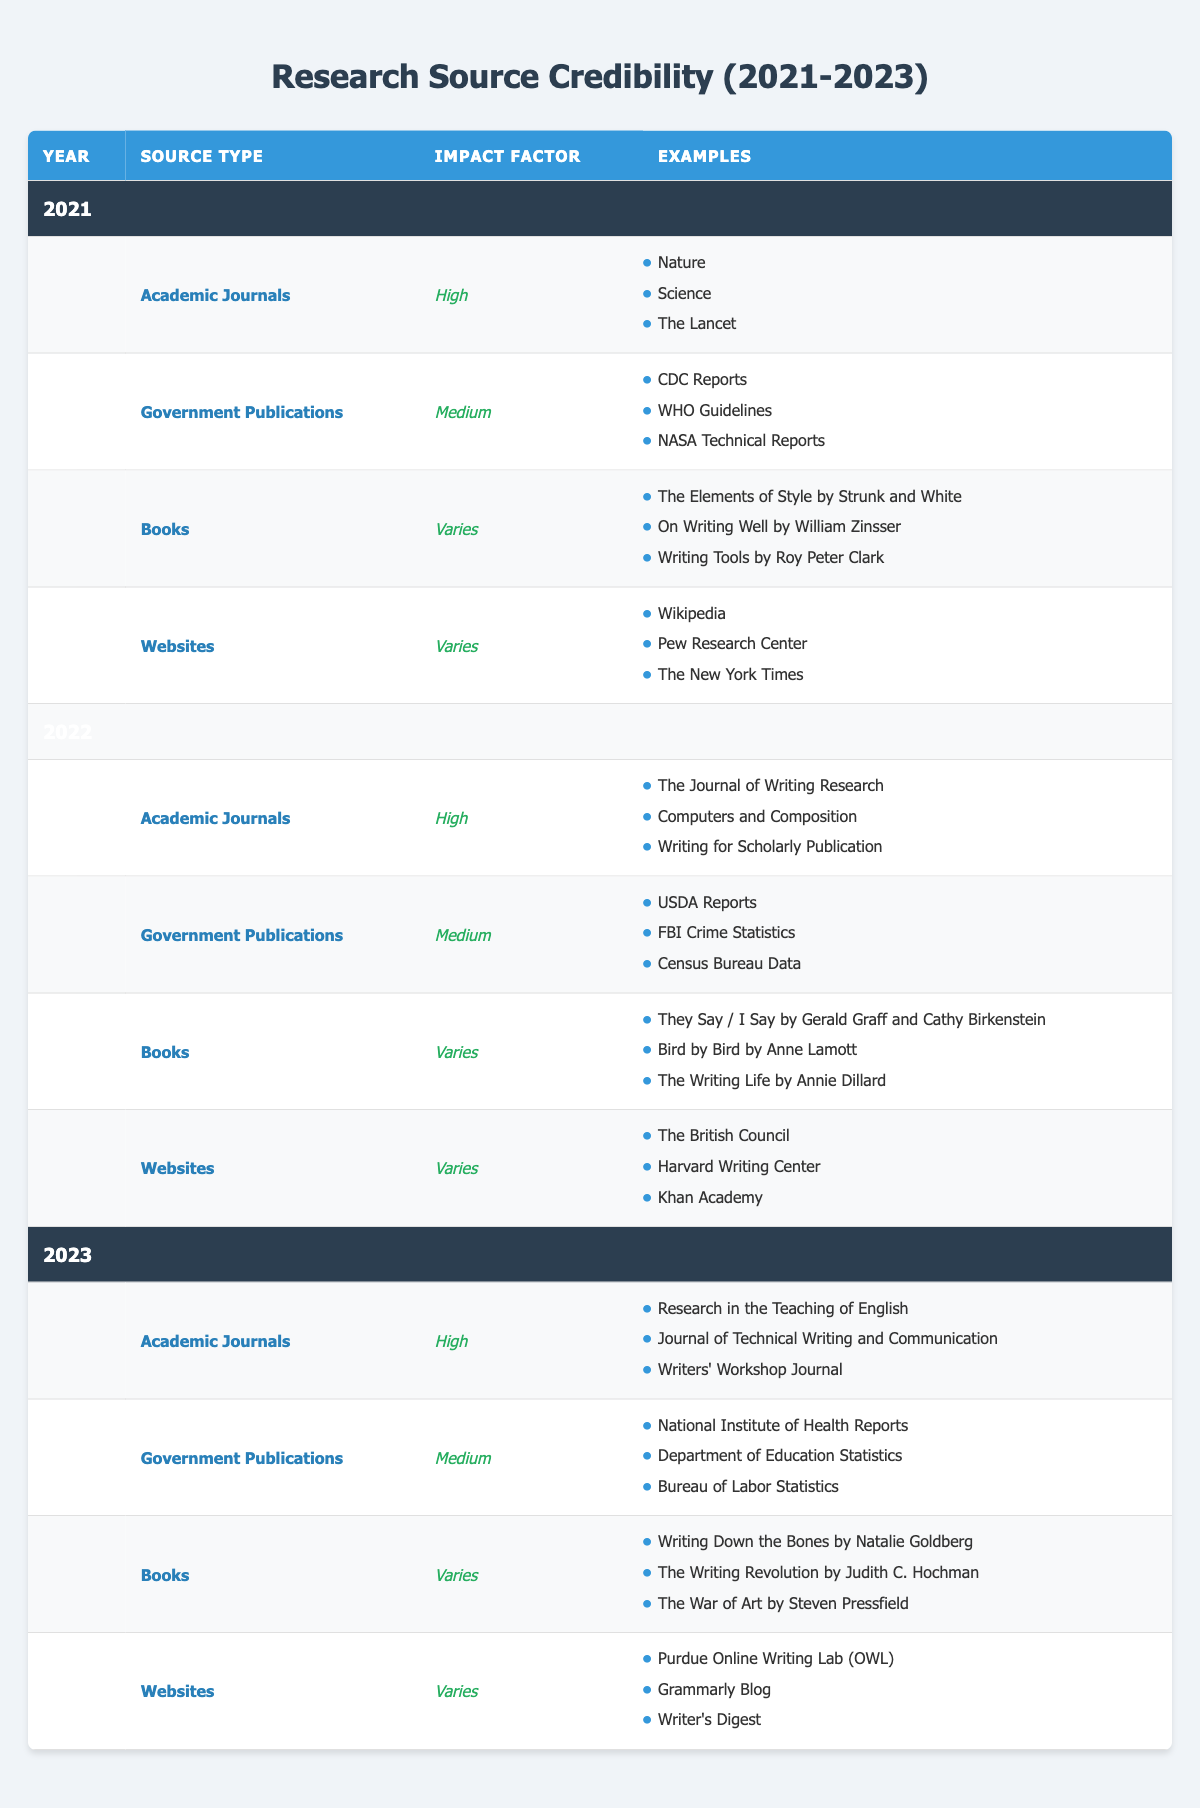What is the impact factor for Academic Journals in 2023? The table shows that the impact factor for Academic Journals in 2023 is categorized as "High."
Answer: High Which year has Government Publications with the highest impact factor? The impact factor for Government Publications is "Medium" for 2021, 2022, and 2023. Since all years have the same rating, there is no year with a higher impact factor.
Answer: None What are the examples listed for Books in 2022? The table list for Books in 2022 includes: "They Say / I Say by Gerald Graff and Cathy Birkenstein," "Bird by Bird by Anne Lamott," and "The Writing Life by Annie Dillard."
Answer: They Say / I Say, Bird by Bird, The Writing Life Is the impact factor for Websites consistent across the years? The impact factor for Websites varies for all three years (2021, 2022, 2023), which means it is not consistent.
Answer: No How many examples of Government Publications are provided for the year 2021? In the year 2021, there are three examples listed under Government Publications: "CDC Reports," "WHO Guidelines," and "NASA Technical Reports."
Answer: 3 What is the difference in the number of unique sources between Academic Journals and Books for 2021? For Academic Journals in 2021, there are 3 unique sources listed, and for Books, there are also 3 unique sources. The difference is 3 - 3 = 0.
Answer: 0 Which writing source type consistently has a high impact factor from 2021 to 2023? By evaluating the table, Academic Journals are consistently noted with a "High" impact factor across all three years.
Answer: Academic Journals What is the average number of examples listed under Websites across the years? Each year lists 3 examples under Websites: 2021 (3), 2022 (3), and 2023 (3). To find the average, we sum them up: (3 + 3 + 3) = 9, and divide by 3 years, giving us 9 / 3 = 3.
Answer: 3 